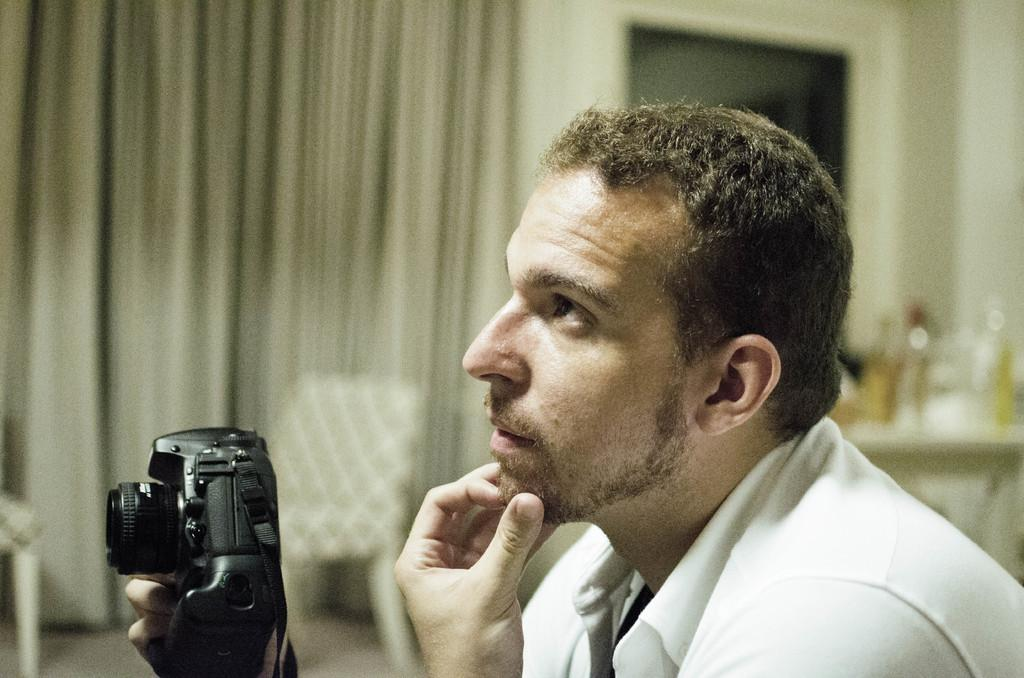What is the person in the image doing? The person is holding a camera in their hands. What is the person wearing in the image? The person is wearing a white shirt. What can be seen in the background of the image? There are curtains, chairs, and a table in the background of the image. Can you describe the coastline visible in the image? There is no coastline visible in the image; it features a person holding a camera and a background with curtains, chairs, and a table. 